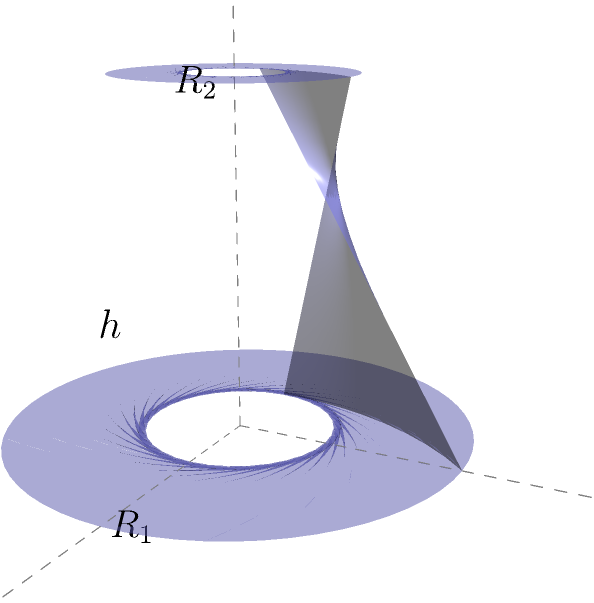As a visual artist who incorporates patterns and symmetry of numbers in your work, you're exploring the concept of truncated cones. Calculate the volume of a truncated cone with lower radius $R_1 = 2$ units, upper radius $R_2 = 1$ unit, and height $h = 3$ units. Express your answer in terms of $\pi$ cubic units. To calculate the volume of a truncated cone, we'll follow these steps:

1) The formula for the volume of a truncated cone is:

   $$V = \frac{1}{3}\pi h(R_1^2 + R_2^2 + R_1R_2)$$

   where $h$ is the height, $R_1$ is the radius of the base, and $R_2$ is the radius of the top.

2) We're given:
   $R_1 = 2$ units
   $R_2 = 1$ unit
   $h = 3$ units

3) Let's substitute these values into the formula:

   $$V = \frac{1}{3}\pi \cdot 3(2^2 + 1^2 + 2 \cdot 1)$$

4) Simplify the expressions inside the parentheses:
   
   $$V = \pi(4 + 1 + 2)$$

5) Add the terms inside the parentheses:

   $$V = 7\pi$$

Therefore, the volume of the truncated cone is $7\pi$ cubic units.
Answer: $7\pi$ cubic units 